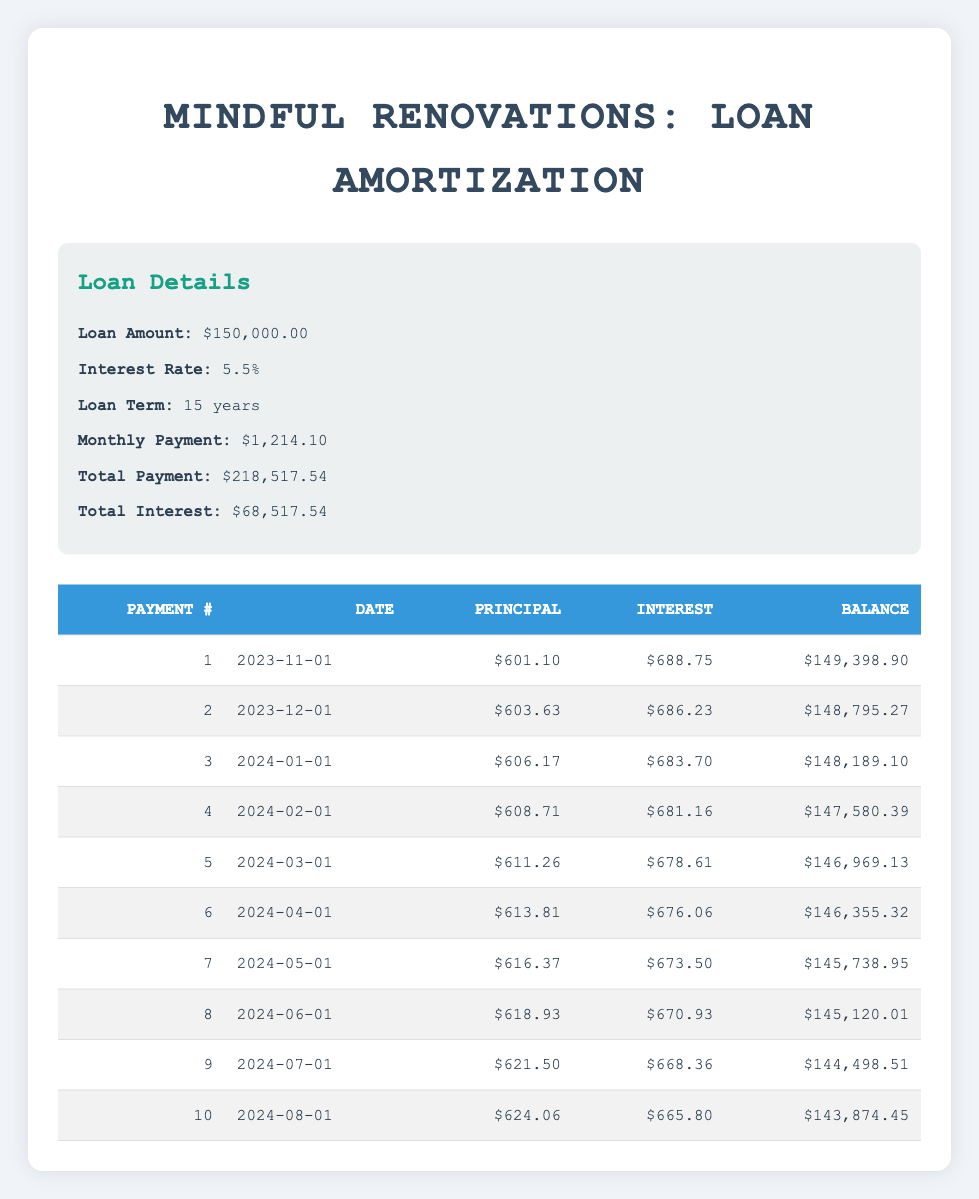What is the monthly payment amount for the loan? The monthly payment amount is clearly listed in the loan details section of the table as 1,214.10.
Answer: 1,214.10 How much interest is paid in the first payment? The first payment's interest amount is provided in the payments schedule table, and it is 688.75.
Answer: 688.75 What is the total interest paid at the end of the loan term? The total interest paid is shown in the loan details section as a total of 68,517.54.
Answer: 68,517.54 How much principal is paid off in the first three payments combined? To find this, we add the principal payments of the first three payments: 601.10 + 603.63 + 606.17 = 1,810.90.
Answer: 1,810.90 Does the remaining loan balance decrease with each payment? Yes, the table shows that with every payment, the remaining balance consistently decreases from 150,000.00 down to figures lower than the previous balance after each payment.
Answer: Yes What is the difference in principal payment between payment number 5 and payment number 1? The principal payment for payment number 5 is 611.26 and for payment number 1 is 601.10. The difference is 611.26 - 601.10 = 10.16.
Answer: 10.16 What is the average interest payment for the first 10 payments? To calculate the average, first sum the interest payments (688.75 + 686.23 + 683.70 + 681.16 + 678.61 + 676.06 + 673.50 + 670.93 + 668.36 + 665.80 = 6,614.10) and divide by the number of payments (10). The average is 6,614.10 / 10 = 661.41.
Answer: 661.41 How much did the remaining balance decrease from the second payment to the third payment? The remaining balance after the second payment is 148,795.27, and after the third payment, it is 148,189.10. The decrease is 148,795.27 - 148,189.10 = 606.17.
Answer: 606.17 How many total payments are left after the 10th payment? Since the loan term is for 15 years and there are 12 monthly payments per year, the total number of payments is 15 * 12 = 180. After the 10th payment, there are 180 - 10 = 170 payments left.
Answer: 170 